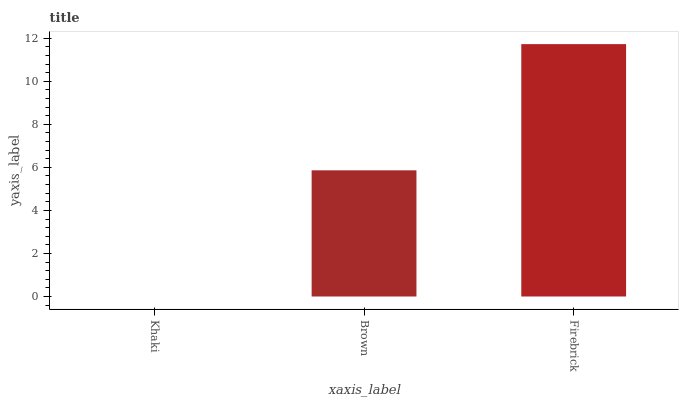Is Khaki the minimum?
Answer yes or no. Yes. Is Firebrick the maximum?
Answer yes or no. Yes. Is Brown the minimum?
Answer yes or no. No. Is Brown the maximum?
Answer yes or no. No. Is Brown greater than Khaki?
Answer yes or no. Yes. Is Khaki less than Brown?
Answer yes or no. Yes. Is Khaki greater than Brown?
Answer yes or no. No. Is Brown less than Khaki?
Answer yes or no. No. Is Brown the high median?
Answer yes or no. Yes. Is Brown the low median?
Answer yes or no. Yes. Is Firebrick the high median?
Answer yes or no. No. Is Firebrick the low median?
Answer yes or no. No. 